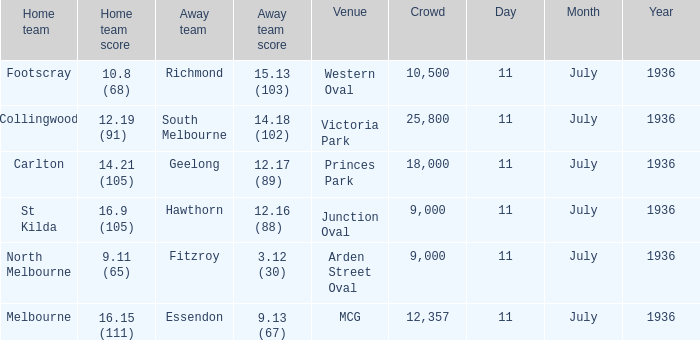What Away team got a team score of 12.16 (88)? Hawthorn. 